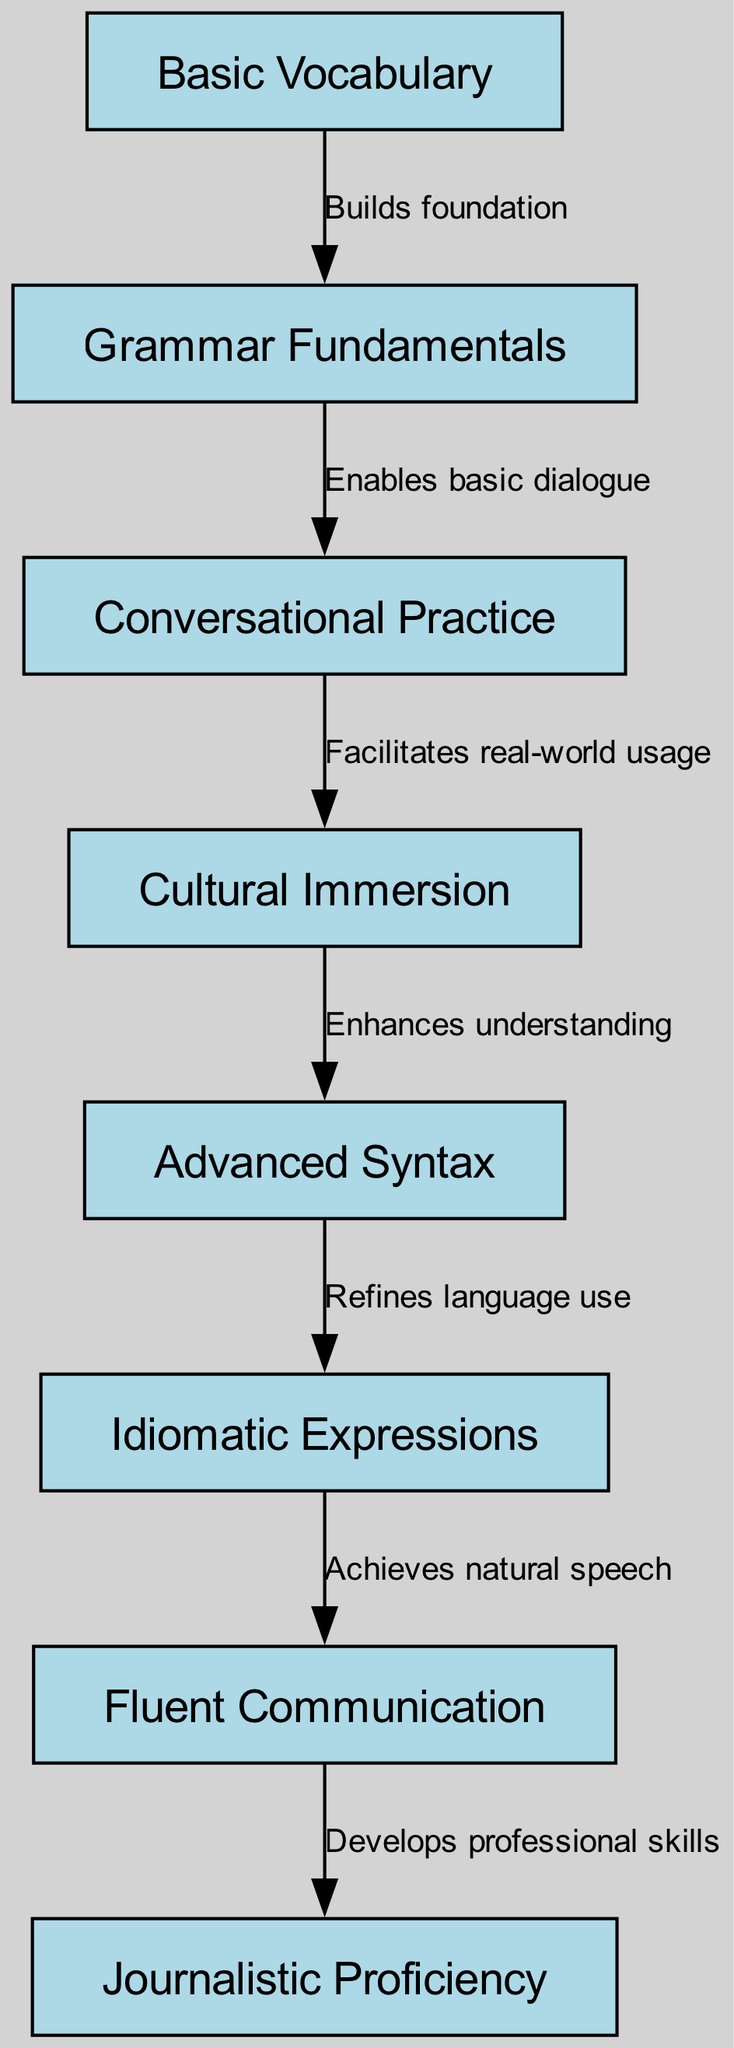What are the nodes in the diagram? The nodes listed represent the stages in language acquisition and fluency progression. They are: Basic Vocabulary, Grammar Fundamentals, Conversational Practice, Cultural Immersion, Advanced Syntax, Idiomatic Expressions, Fluent Communication, and Journalistic Proficiency.
Answer: Basic Vocabulary, Grammar Fundamentals, Conversational Practice, Cultural Immersion, Advanced Syntax, Idiomatic Expressions, Fluent Communication, Journalistic Proficiency How many nodes are present in the diagram? The nodes include all stages of language learning outlined in the diagram. Counting them, there are a total of eight nodes.
Answer: 8 What edge connects Basic Vocabulary to Grammar Fundamentals? The diagram specifies that the edge from Basic Vocabulary to Grammar Fundamentals is labeled "Builds foundation," indicating the relationship between these two stages.
Answer: Builds foundation What is the final node in the progression? By following the flow of the directed graph, the last node leads to Journalistic Proficiency, which represents a higher level of skill in language use.
Answer: Journalistic Proficiency Which stage comes directly before Idiomatic Expressions? Analyzing the edges leading into Idiomatic Expressions, it's clear that it follows Advanced Syntax in the progression, demonstrating a refined aspect of the language learning process.
Answer: Advanced Syntax What does Cultural Immersion facilitate? The flow of the diagram indicates that Cultural Immersion facilitates real-world usage, enhancing practical language application.
Answer: Real-world usage How does Fluent Communication relate to Journalistic Proficiency? The edge directed from Fluent Communication to Journalistic Proficiency is labeled "Develops professional skills," showing a direct connection indicating that fluency leads to advanced professional capabilities in language.
Answer: Develops professional skills What is the overall direction of the graph? The directed graph illustrates a clear progression from initial language concepts to advanced linguistic skills, moving from the bottom to the top, implying a sequential development in language fluency.
Answer: Bottom to top 